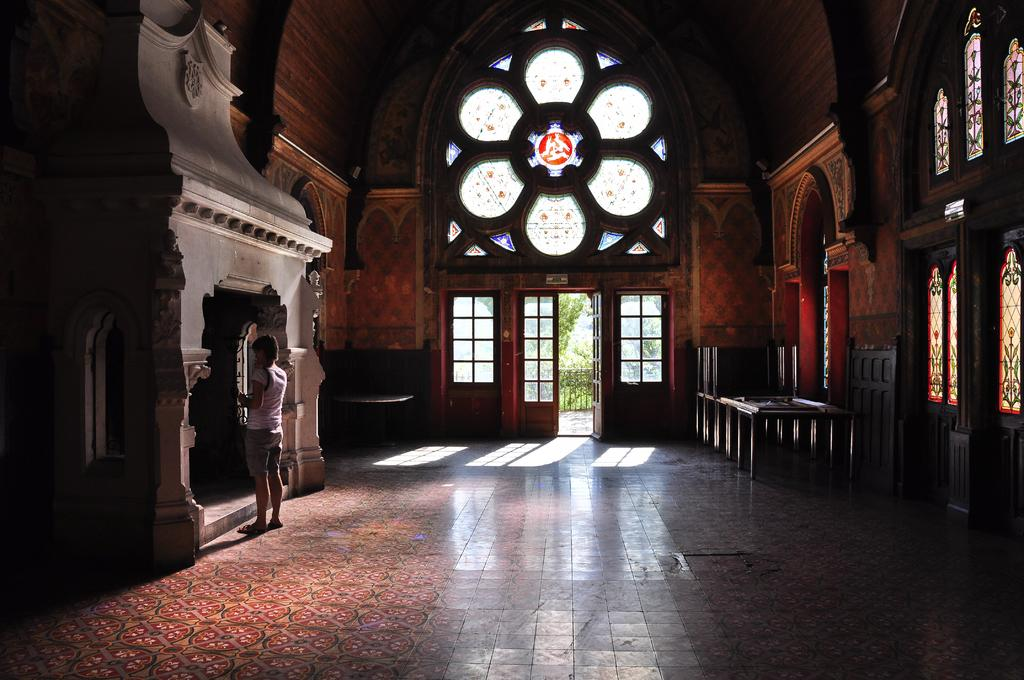What type of location is depicted in the image? The image shows an inner view of a building. Can you describe any people present in the image? There is a woman standing in the image. What type of furniture is visible in the image? There are tables visible in the image. What type of acoustics can be heard in the image? There is no information about the acoustics in the image, as it only shows a visual representation of a building interior. Is there a glass object visible in the image? The provided facts do not mention any glass objects in the image. 